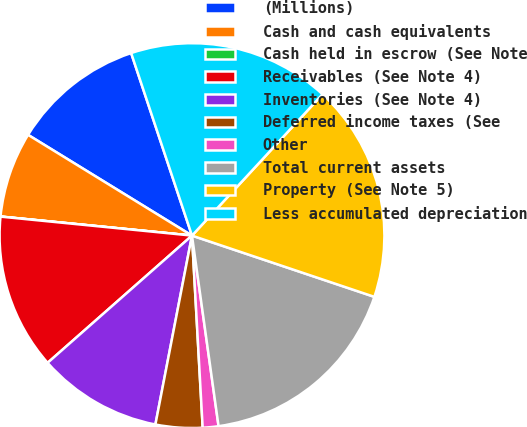Convert chart. <chart><loc_0><loc_0><loc_500><loc_500><pie_chart><fcel>(Millions)<fcel>Cash and cash equivalents<fcel>Cash held in escrow (See Note<fcel>Receivables (See Note 4)<fcel>Inventories (See Note 4)<fcel>Deferred income taxes (See<fcel>Other<fcel>Total current assets<fcel>Property (See Note 5)<fcel>Less accumulated depreciation<nl><fcel>11.11%<fcel>7.19%<fcel>0.01%<fcel>13.07%<fcel>10.46%<fcel>3.93%<fcel>1.32%<fcel>17.64%<fcel>18.29%<fcel>16.99%<nl></chart> 